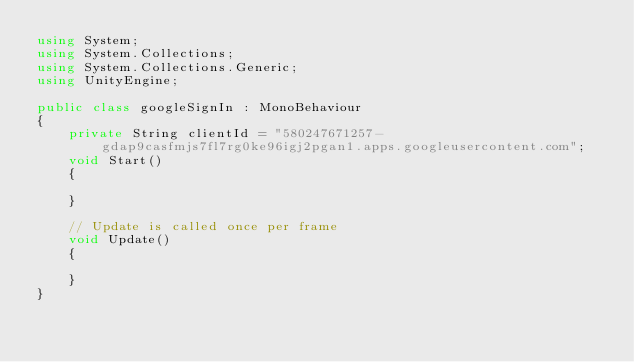Convert code to text. <code><loc_0><loc_0><loc_500><loc_500><_C#_>using System;
using System.Collections;
using System.Collections.Generic;
using UnityEngine;

public class googleSignIn : MonoBehaviour
{
    private String clientId = "580247671257-gdap9casfmjs7fl7rg0ke96igj2pgan1.apps.googleusercontent.com";
    void Start()
    {
        
    }

    // Update is called once per frame
    void Update()
    {
        
    }
}
</code> 